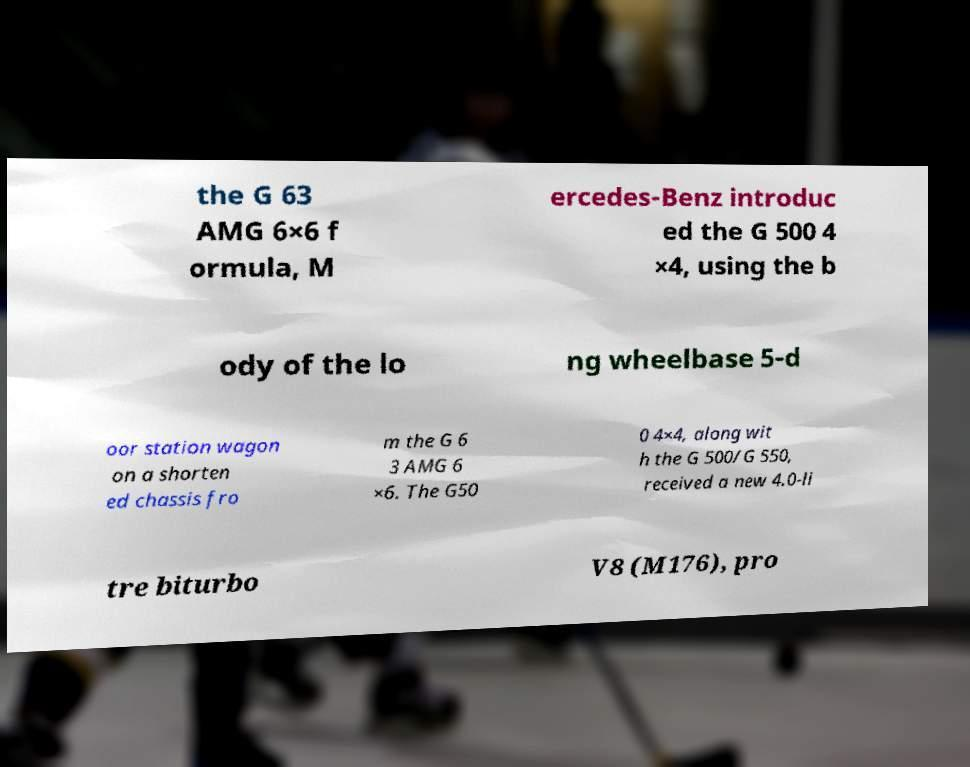Can you read and provide the text displayed in the image?This photo seems to have some interesting text. Can you extract and type it out for me? the G 63 AMG 6×6 f ormula, M ercedes-Benz introduc ed the G 500 4 ×4, using the b ody of the lo ng wheelbase 5-d oor station wagon on a shorten ed chassis fro m the G 6 3 AMG 6 ×6. The G50 0 4×4, along wit h the G 500/G 550, received a new 4.0-li tre biturbo V8 (M176), pro 